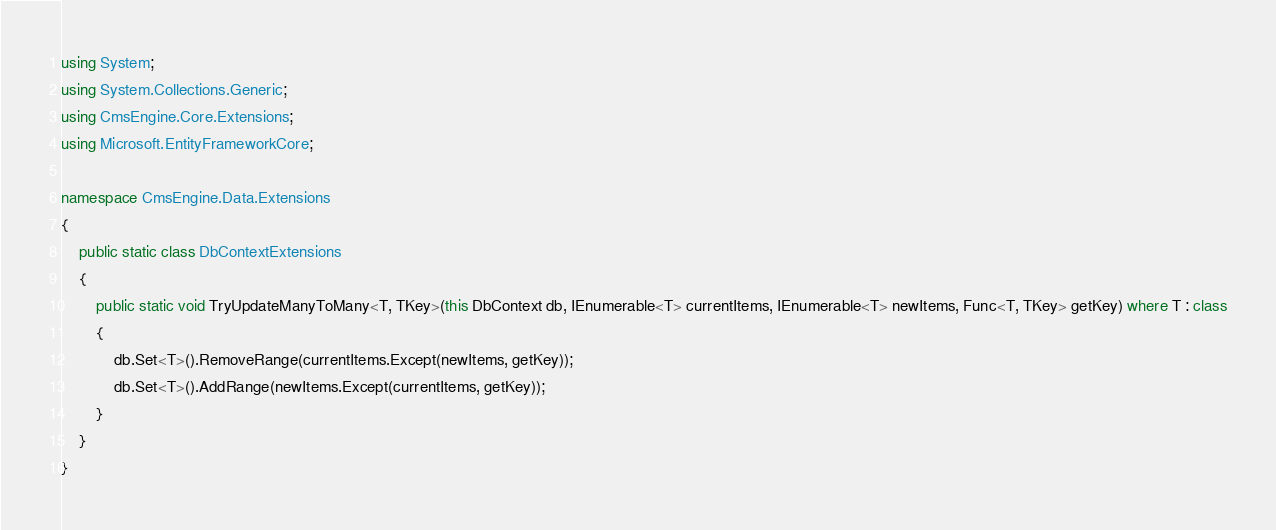<code> <loc_0><loc_0><loc_500><loc_500><_C#_>using System;
using System.Collections.Generic;
using CmsEngine.Core.Extensions;
using Microsoft.EntityFrameworkCore;

namespace CmsEngine.Data.Extensions
{
    public static class DbContextExtensions
    {
        public static void TryUpdateManyToMany<T, TKey>(this DbContext db, IEnumerable<T> currentItems, IEnumerable<T> newItems, Func<T, TKey> getKey) where T : class
        {
            db.Set<T>().RemoveRange(currentItems.Except(newItems, getKey));
            db.Set<T>().AddRange(newItems.Except(currentItems, getKey));
        }
    }
}
</code> 